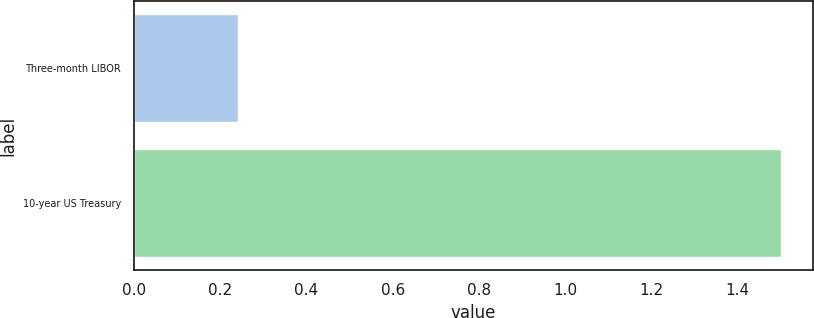Convert chart to OTSL. <chart><loc_0><loc_0><loc_500><loc_500><bar_chart><fcel>Three-month LIBOR<fcel>10-year US Treasury<nl><fcel>0.24<fcel>1.5<nl></chart> 